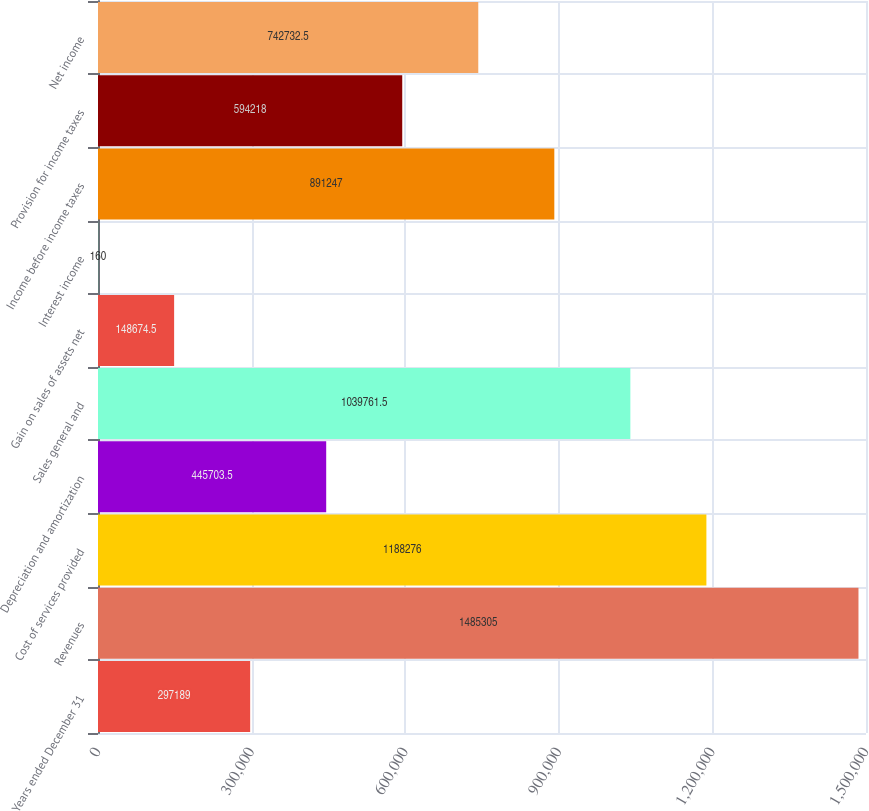Convert chart to OTSL. <chart><loc_0><loc_0><loc_500><loc_500><bar_chart><fcel>Years ended December 31<fcel>Revenues<fcel>Cost of services provided<fcel>Depreciation and amortization<fcel>Sales general and<fcel>Gain on sales of assets net<fcel>Interest income<fcel>Income before income taxes<fcel>Provision for income taxes<fcel>Net income<nl><fcel>297189<fcel>1.4853e+06<fcel>1.18828e+06<fcel>445704<fcel>1.03976e+06<fcel>148674<fcel>160<fcel>891247<fcel>594218<fcel>742732<nl></chart> 